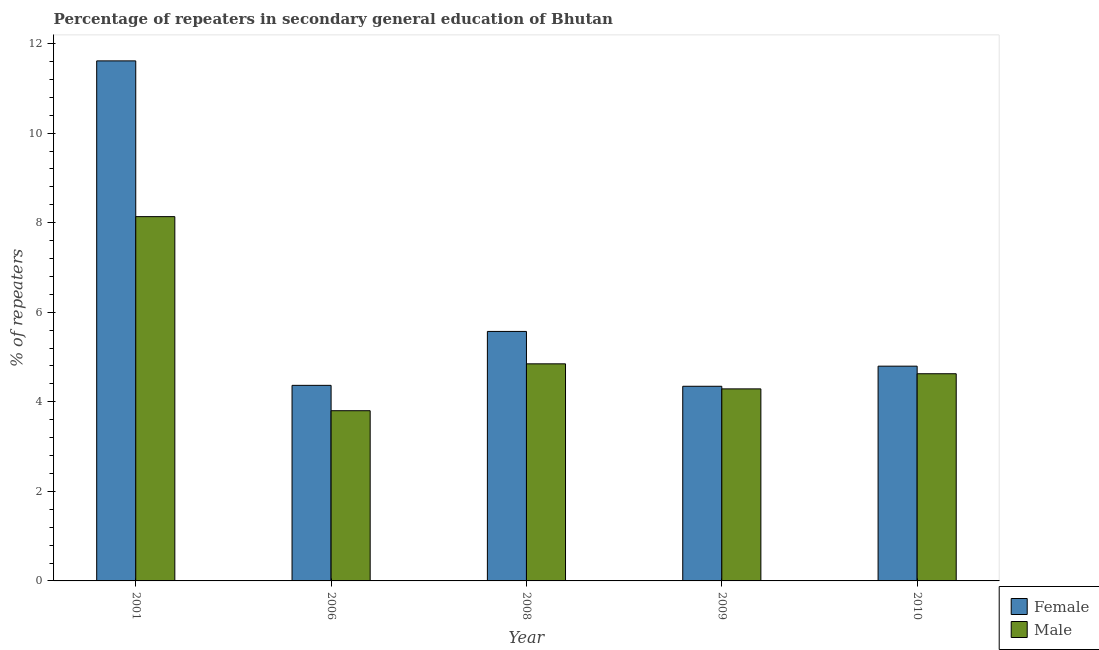How many different coloured bars are there?
Provide a succinct answer. 2. How many groups of bars are there?
Provide a succinct answer. 5. Are the number of bars on each tick of the X-axis equal?
Ensure brevity in your answer.  Yes. How many bars are there on the 2nd tick from the left?
Ensure brevity in your answer.  2. How many bars are there on the 1st tick from the right?
Keep it short and to the point. 2. What is the label of the 5th group of bars from the left?
Your response must be concise. 2010. What is the percentage of female repeaters in 2010?
Offer a very short reply. 4.8. Across all years, what is the maximum percentage of female repeaters?
Offer a very short reply. 11.61. Across all years, what is the minimum percentage of female repeaters?
Make the answer very short. 4.35. In which year was the percentage of male repeaters maximum?
Keep it short and to the point. 2001. What is the total percentage of male repeaters in the graph?
Provide a short and direct response. 25.7. What is the difference between the percentage of male repeaters in 2008 and that in 2010?
Make the answer very short. 0.22. What is the difference between the percentage of female repeaters in 2010 and the percentage of male repeaters in 2006?
Your answer should be compact. 0.43. What is the average percentage of male repeaters per year?
Offer a very short reply. 5.14. In the year 2009, what is the difference between the percentage of female repeaters and percentage of male repeaters?
Offer a very short reply. 0. What is the ratio of the percentage of male repeaters in 2009 to that in 2010?
Your answer should be very brief. 0.93. Is the percentage of male repeaters in 2008 less than that in 2010?
Ensure brevity in your answer.  No. What is the difference between the highest and the second highest percentage of male repeaters?
Keep it short and to the point. 3.29. What is the difference between the highest and the lowest percentage of female repeaters?
Make the answer very short. 7.27. Are all the bars in the graph horizontal?
Your response must be concise. No. How many years are there in the graph?
Your answer should be very brief. 5. Does the graph contain any zero values?
Provide a short and direct response. No. How are the legend labels stacked?
Give a very brief answer. Vertical. What is the title of the graph?
Offer a very short reply. Percentage of repeaters in secondary general education of Bhutan. What is the label or title of the Y-axis?
Provide a succinct answer. % of repeaters. What is the % of repeaters in Female in 2001?
Provide a short and direct response. 11.61. What is the % of repeaters of Male in 2001?
Your answer should be very brief. 8.13. What is the % of repeaters in Female in 2006?
Provide a short and direct response. 4.37. What is the % of repeaters in Male in 2006?
Your answer should be compact. 3.8. What is the % of repeaters of Female in 2008?
Ensure brevity in your answer.  5.57. What is the % of repeaters of Male in 2008?
Make the answer very short. 4.85. What is the % of repeaters in Female in 2009?
Your answer should be very brief. 4.35. What is the % of repeaters in Male in 2009?
Offer a terse response. 4.29. What is the % of repeaters in Female in 2010?
Offer a terse response. 4.8. What is the % of repeaters in Male in 2010?
Offer a terse response. 4.63. Across all years, what is the maximum % of repeaters in Female?
Your answer should be very brief. 11.61. Across all years, what is the maximum % of repeaters of Male?
Ensure brevity in your answer.  8.13. Across all years, what is the minimum % of repeaters of Female?
Make the answer very short. 4.35. Across all years, what is the minimum % of repeaters of Male?
Provide a succinct answer. 3.8. What is the total % of repeaters in Female in the graph?
Ensure brevity in your answer.  30.69. What is the total % of repeaters in Male in the graph?
Your answer should be very brief. 25.7. What is the difference between the % of repeaters in Female in 2001 and that in 2006?
Provide a short and direct response. 7.25. What is the difference between the % of repeaters of Male in 2001 and that in 2006?
Your response must be concise. 4.33. What is the difference between the % of repeaters of Female in 2001 and that in 2008?
Make the answer very short. 6.04. What is the difference between the % of repeaters in Male in 2001 and that in 2008?
Your answer should be very brief. 3.29. What is the difference between the % of repeaters of Female in 2001 and that in 2009?
Your answer should be very brief. 7.27. What is the difference between the % of repeaters in Male in 2001 and that in 2009?
Make the answer very short. 3.85. What is the difference between the % of repeaters in Female in 2001 and that in 2010?
Offer a terse response. 6.82. What is the difference between the % of repeaters of Male in 2001 and that in 2010?
Provide a short and direct response. 3.51. What is the difference between the % of repeaters of Female in 2006 and that in 2008?
Keep it short and to the point. -1.2. What is the difference between the % of repeaters of Male in 2006 and that in 2008?
Provide a short and direct response. -1.05. What is the difference between the % of repeaters of Female in 2006 and that in 2009?
Your answer should be compact. 0.02. What is the difference between the % of repeaters of Male in 2006 and that in 2009?
Your answer should be compact. -0.49. What is the difference between the % of repeaters of Female in 2006 and that in 2010?
Make the answer very short. -0.43. What is the difference between the % of repeaters in Male in 2006 and that in 2010?
Give a very brief answer. -0.83. What is the difference between the % of repeaters of Female in 2008 and that in 2009?
Your answer should be compact. 1.22. What is the difference between the % of repeaters in Male in 2008 and that in 2009?
Offer a terse response. 0.56. What is the difference between the % of repeaters in Female in 2008 and that in 2010?
Offer a terse response. 0.78. What is the difference between the % of repeaters of Male in 2008 and that in 2010?
Give a very brief answer. 0.22. What is the difference between the % of repeaters of Female in 2009 and that in 2010?
Offer a terse response. -0.45. What is the difference between the % of repeaters of Male in 2009 and that in 2010?
Offer a terse response. -0.34. What is the difference between the % of repeaters in Female in 2001 and the % of repeaters in Male in 2006?
Keep it short and to the point. 7.81. What is the difference between the % of repeaters of Female in 2001 and the % of repeaters of Male in 2008?
Make the answer very short. 6.76. What is the difference between the % of repeaters in Female in 2001 and the % of repeaters in Male in 2009?
Your response must be concise. 7.32. What is the difference between the % of repeaters in Female in 2001 and the % of repeaters in Male in 2010?
Offer a very short reply. 6.99. What is the difference between the % of repeaters of Female in 2006 and the % of repeaters of Male in 2008?
Your answer should be very brief. -0.48. What is the difference between the % of repeaters in Female in 2006 and the % of repeaters in Male in 2009?
Ensure brevity in your answer.  0.08. What is the difference between the % of repeaters in Female in 2006 and the % of repeaters in Male in 2010?
Offer a terse response. -0.26. What is the difference between the % of repeaters in Female in 2008 and the % of repeaters in Male in 2009?
Ensure brevity in your answer.  1.28. What is the difference between the % of repeaters in Female in 2008 and the % of repeaters in Male in 2010?
Provide a short and direct response. 0.94. What is the difference between the % of repeaters of Female in 2009 and the % of repeaters of Male in 2010?
Give a very brief answer. -0.28. What is the average % of repeaters of Female per year?
Your response must be concise. 6.14. What is the average % of repeaters in Male per year?
Provide a succinct answer. 5.14. In the year 2001, what is the difference between the % of repeaters in Female and % of repeaters in Male?
Provide a succinct answer. 3.48. In the year 2006, what is the difference between the % of repeaters in Female and % of repeaters in Male?
Your response must be concise. 0.57. In the year 2008, what is the difference between the % of repeaters in Female and % of repeaters in Male?
Keep it short and to the point. 0.72. In the year 2009, what is the difference between the % of repeaters in Female and % of repeaters in Male?
Ensure brevity in your answer.  0.06. In the year 2010, what is the difference between the % of repeaters in Female and % of repeaters in Male?
Provide a succinct answer. 0.17. What is the ratio of the % of repeaters of Female in 2001 to that in 2006?
Your answer should be very brief. 2.66. What is the ratio of the % of repeaters of Male in 2001 to that in 2006?
Provide a succinct answer. 2.14. What is the ratio of the % of repeaters in Female in 2001 to that in 2008?
Give a very brief answer. 2.08. What is the ratio of the % of repeaters in Male in 2001 to that in 2008?
Offer a terse response. 1.68. What is the ratio of the % of repeaters in Female in 2001 to that in 2009?
Give a very brief answer. 2.67. What is the ratio of the % of repeaters of Male in 2001 to that in 2009?
Provide a succinct answer. 1.9. What is the ratio of the % of repeaters of Female in 2001 to that in 2010?
Ensure brevity in your answer.  2.42. What is the ratio of the % of repeaters of Male in 2001 to that in 2010?
Your response must be concise. 1.76. What is the ratio of the % of repeaters in Female in 2006 to that in 2008?
Offer a very short reply. 0.78. What is the ratio of the % of repeaters of Male in 2006 to that in 2008?
Offer a very short reply. 0.78. What is the ratio of the % of repeaters in Male in 2006 to that in 2009?
Ensure brevity in your answer.  0.89. What is the ratio of the % of repeaters in Female in 2006 to that in 2010?
Your answer should be very brief. 0.91. What is the ratio of the % of repeaters in Male in 2006 to that in 2010?
Your response must be concise. 0.82. What is the ratio of the % of repeaters of Female in 2008 to that in 2009?
Keep it short and to the point. 1.28. What is the ratio of the % of repeaters in Male in 2008 to that in 2009?
Give a very brief answer. 1.13. What is the ratio of the % of repeaters in Female in 2008 to that in 2010?
Keep it short and to the point. 1.16. What is the ratio of the % of repeaters of Male in 2008 to that in 2010?
Give a very brief answer. 1.05. What is the ratio of the % of repeaters in Female in 2009 to that in 2010?
Offer a terse response. 0.91. What is the ratio of the % of repeaters in Male in 2009 to that in 2010?
Provide a succinct answer. 0.93. What is the difference between the highest and the second highest % of repeaters in Female?
Keep it short and to the point. 6.04. What is the difference between the highest and the second highest % of repeaters of Male?
Keep it short and to the point. 3.29. What is the difference between the highest and the lowest % of repeaters of Female?
Offer a terse response. 7.27. What is the difference between the highest and the lowest % of repeaters in Male?
Provide a short and direct response. 4.33. 